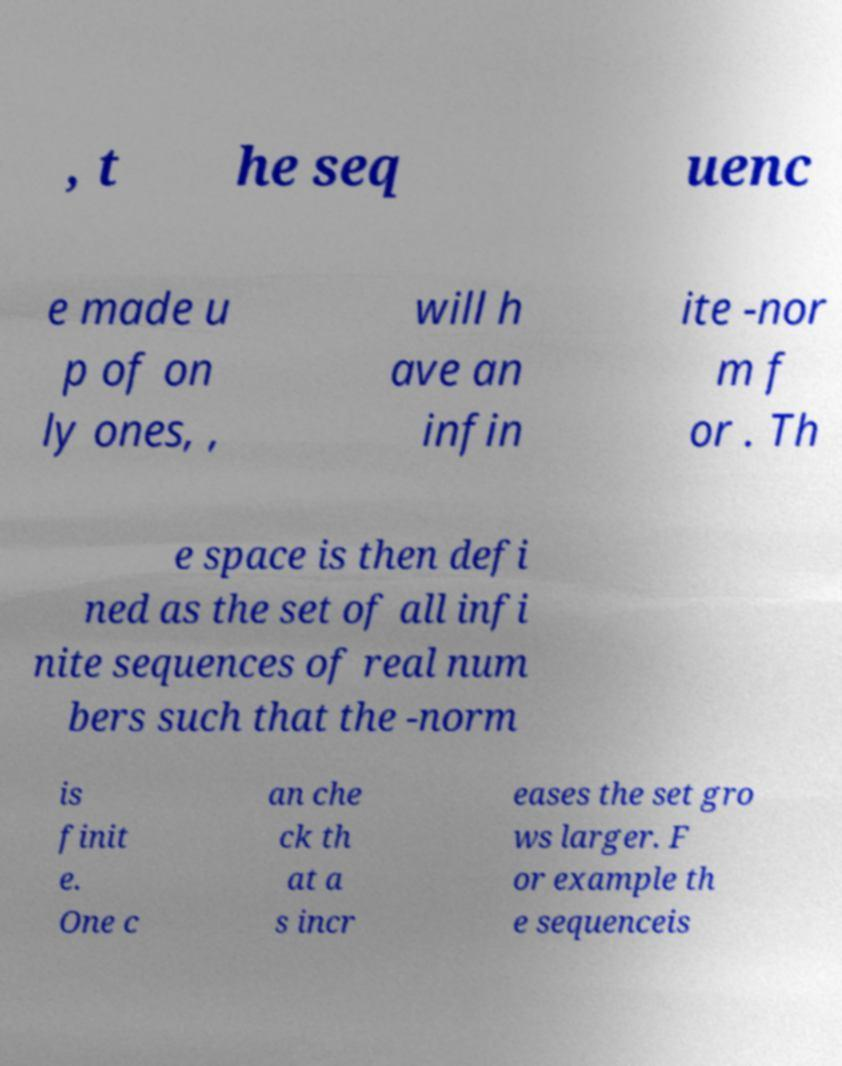Can you accurately transcribe the text from the provided image for me? , t he seq uenc e made u p of on ly ones, , will h ave an infin ite -nor m f or . Th e space is then defi ned as the set of all infi nite sequences of real num bers such that the -norm is finit e. One c an che ck th at a s incr eases the set gro ws larger. F or example th e sequenceis 